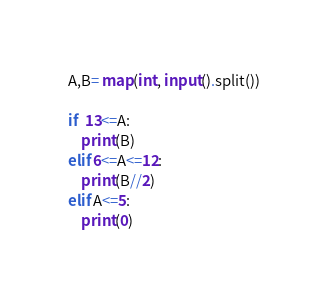<code> <loc_0><loc_0><loc_500><loc_500><_Python_>A,B= map(int, input().split())

if  13<=A:
    print(B)
elif 6<=A<=12:
    print(B//2)
elif A<=5:
    print(0)</code> 